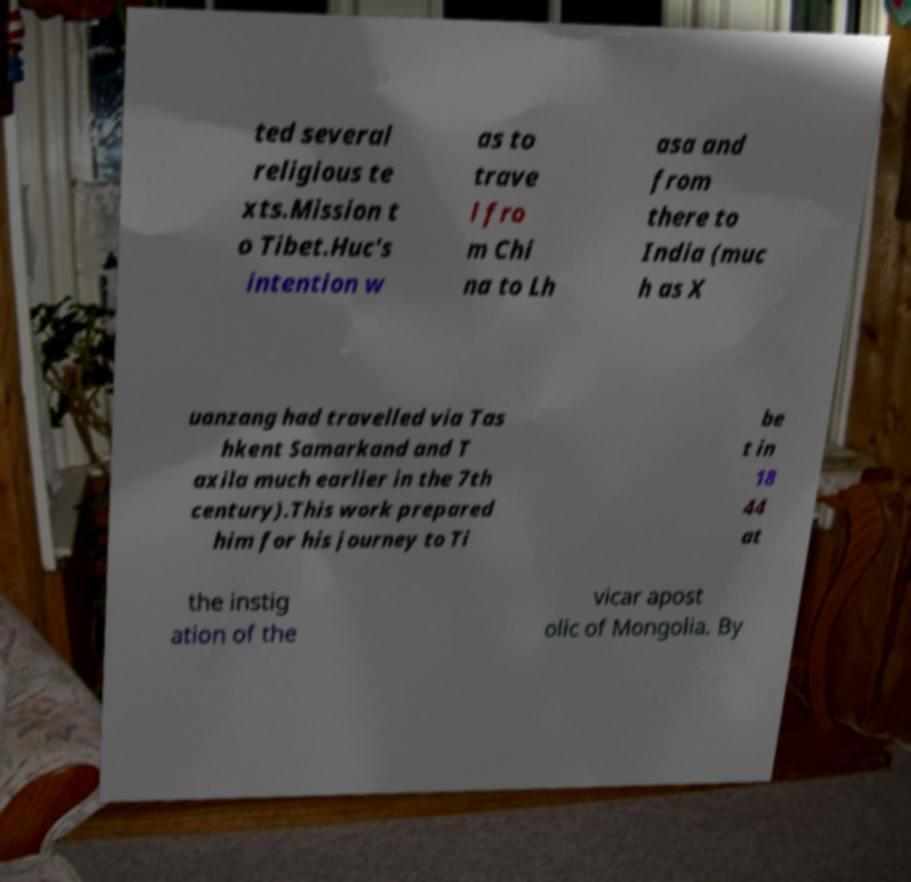Please read and relay the text visible in this image. What does it say? ted several religious te xts.Mission t o Tibet.Huc's intention w as to trave l fro m Chi na to Lh asa and from there to India (muc h as X uanzang had travelled via Tas hkent Samarkand and T axila much earlier in the 7th century).This work prepared him for his journey to Ti be t in 18 44 at the instig ation of the vicar apost olic of Mongolia. By 